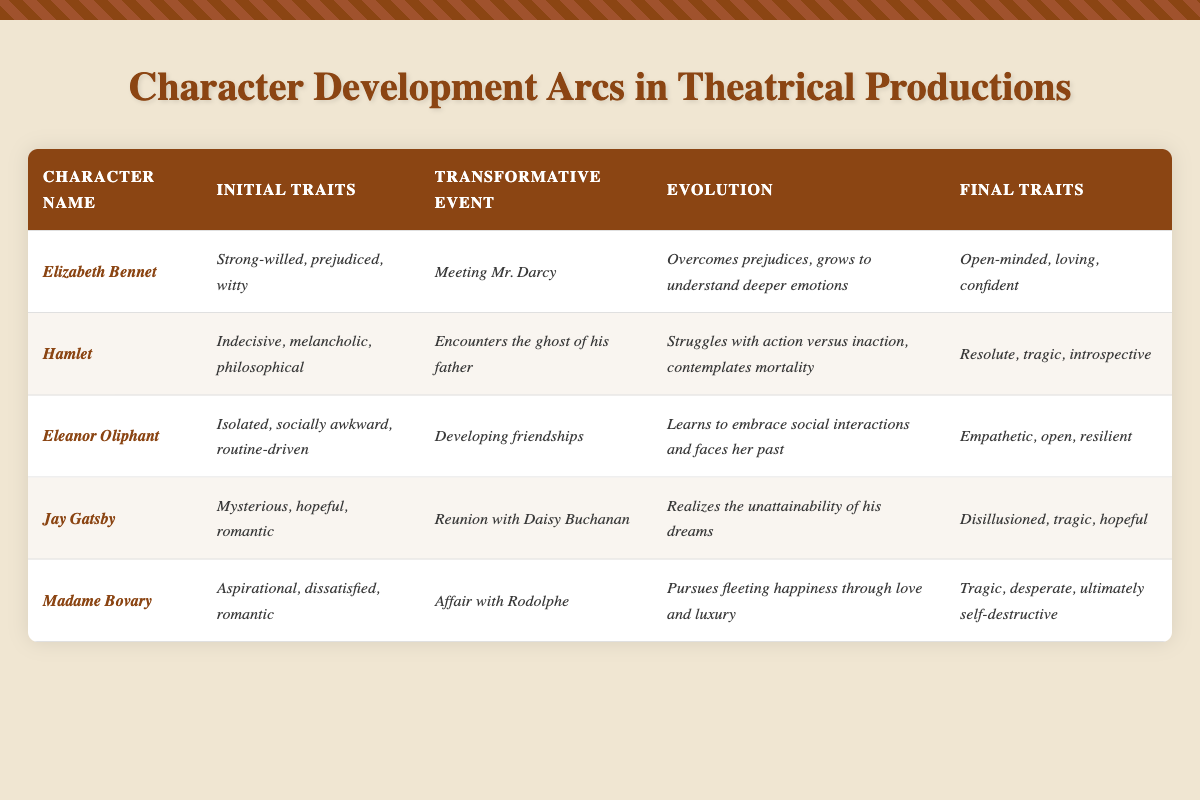What are the initial traits of Elizabeth Bennet? The table specifies that Elizabeth Bennet's initial traits are "Strong-willed, prejudiced, witty." I can find this information directly under the "Initial Traits" column for her character in the table.
Answer: Strong-willed, prejudiced, witty What transformative event does Hamlet experience? According to the table, Hamlet encounters the ghost of his father which is listed under the "Transformative Event" column.
Answer: Encounters the ghost of his father Which character evolves to become empathetic and open? The table shows that Eleanor Oliphant has final traits listed as "Empathetic, open, resilient," indicating her evolution towards these qualities.
Answer: Eleanor Oliphant True or False: Jay Gatsby's final traits include being disillusioned and hopeless. The table lists Jay Gatsby's final traits as "Disillusioned, tragic, hopeful." Since "hopeless" is not stated, this statement is false.
Answer: False What is the evolution of Elizabeth Bennet? To answer this, I refer to the "Evolution" column for Elizabeth Bennet, which states she "Overcomes prejudices, grows to understand deeper emotions." This is her character arc as presented.
Answer: Overcomes prejudices, grows to understand deeper emotions Which character's final traits reflect a self-destructive nature? The table indicates that Madame Bovary’s final traits are "Tragic, desperate, ultimately self-destructive." This shows her arc concludes with self-destructive characteristics.
Answer: Madame Bovary What can be inferred about the character arc of Hamlet concerning mortality? The evolution line for Hamlet mentions "Struggles with action versus inaction, contemplates mortality," indicating a deep engagement with the concept of mortality throughout his arc. This suggests a significant developmental struggle centered around life and death themes.
Answer: Hamlet Compare the transformative events of Eleanor Oliphant and Madame Bovary. Eleanor Oliphant's transformative event is "Developing friendships," while Madame Bovary's is "Affair with Rodolphe." Both events change the characters significantly but are different in nature—social versus romantic. This comparison highlights different pathways of personal transformation.
Answer: Different in nature: social vs. romantic Which character demonstrates a consistent evolution towards confidence? Elizabeth Bennet shows an evolution from prejudiced traits to being "Open-minded, loving, confident." This signifies her growth and increasing confidence throughout her character arc.
Answer: Elizabeth Bennet Calculate the total number of characters listed who have undergone a tragic arc. The table identifies Hamlet, Jay Gatsby, and Madame Bovary as characters with traits associated with tragedy. Hence, there are three tragic character arcs.
Answer: Three 